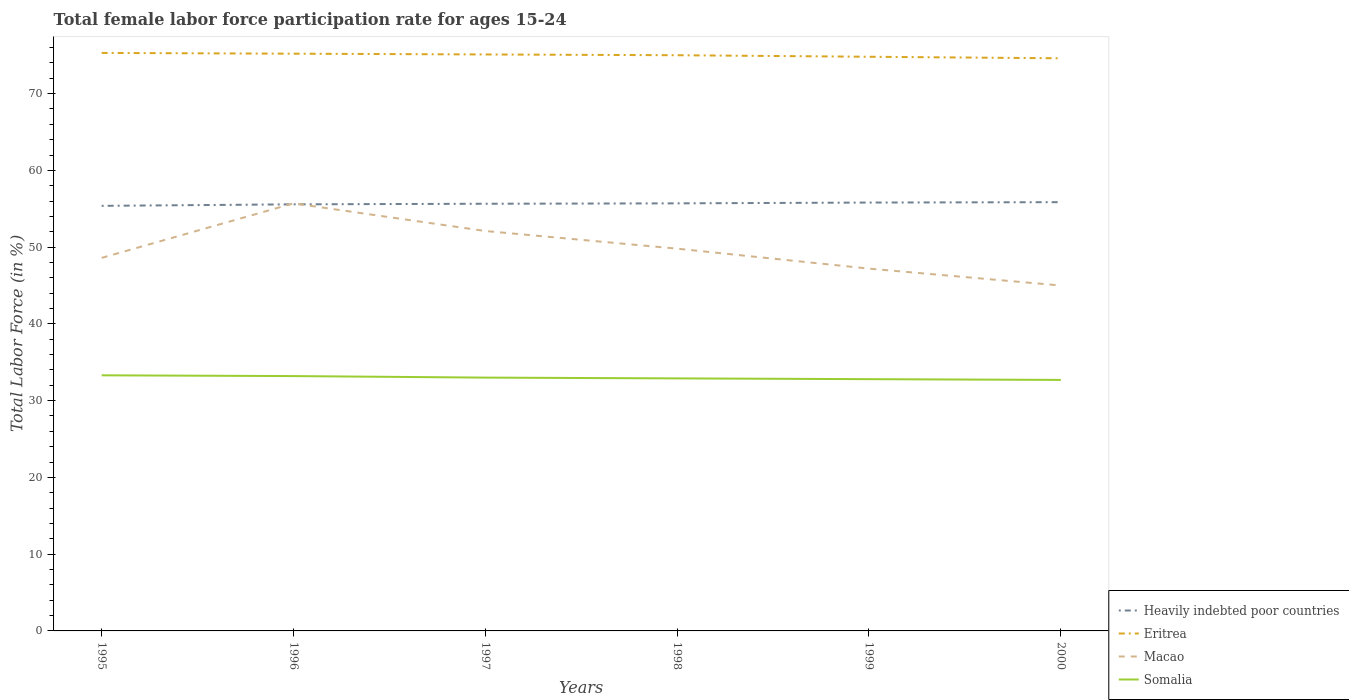Does the line corresponding to Somalia intersect with the line corresponding to Macao?
Offer a terse response. No. Across all years, what is the maximum female labor force participation rate in Heavily indebted poor countries?
Your answer should be compact. 55.38. In which year was the female labor force participation rate in Macao maximum?
Your answer should be very brief. 2000. What is the total female labor force participation rate in Eritrea in the graph?
Give a very brief answer. 0.1. What is the difference between the highest and the second highest female labor force participation rate in Somalia?
Keep it short and to the point. 0.6. What is the difference between the highest and the lowest female labor force participation rate in Heavily indebted poor countries?
Offer a terse response. 3. Is the female labor force participation rate in Heavily indebted poor countries strictly greater than the female labor force participation rate in Somalia over the years?
Offer a very short reply. No. Are the values on the major ticks of Y-axis written in scientific E-notation?
Keep it short and to the point. No. Does the graph contain grids?
Your answer should be very brief. No. Where does the legend appear in the graph?
Make the answer very short. Bottom right. What is the title of the graph?
Your answer should be very brief. Total female labor force participation rate for ages 15-24. What is the label or title of the X-axis?
Your response must be concise. Years. What is the Total Labor Force (in %) of Heavily indebted poor countries in 1995?
Provide a succinct answer. 55.38. What is the Total Labor Force (in %) of Eritrea in 1995?
Your answer should be compact. 75.3. What is the Total Labor Force (in %) in Macao in 1995?
Your response must be concise. 48.6. What is the Total Labor Force (in %) in Somalia in 1995?
Your response must be concise. 33.3. What is the Total Labor Force (in %) in Heavily indebted poor countries in 1996?
Keep it short and to the point. 55.57. What is the Total Labor Force (in %) in Eritrea in 1996?
Provide a succinct answer. 75.2. What is the Total Labor Force (in %) in Macao in 1996?
Keep it short and to the point. 55.7. What is the Total Labor Force (in %) of Somalia in 1996?
Offer a terse response. 33.2. What is the Total Labor Force (in %) in Heavily indebted poor countries in 1997?
Your response must be concise. 55.65. What is the Total Labor Force (in %) of Eritrea in 1997?
Give a very brief answer. 75.1. What is the Total Labor Force (in %) in Macao in 1997?
Make the answer very short. 52.1. What is the Total Labor Force (in %) in Heavily indebted poor countries in 1998?
Offer a very short reply. 55.7. What is the Total Labor Force (in %) of Eritrea in 1998?
Provide a short and direct response. 75. What is the Total Labor Force (in %) of Macao in 1998?
Offer a very short reply. 49.8. What is the Total Labor Force (in %) in Somalia in 1998?
Offer a very short reply. 32.9. What is the Total Labor Force (in %) of Heavily indebted poor countries in 1999?
Your answer should be compact. 55.81. What is the Total Labor Force (in %) in Eritrea in 1999?
Your answer should be compact. 74.8. What is the Total Labor Force (in %) in Macao in 1999?
Provide a succinct answer. 47.2. What is the Total Labor Force (in %) in Somalia in 1999?
Provide a short and direct response. 32.8. What is the Total Labor Force (in %) in Heavily indebted poor countries in 2000?
Your answer should be compact. 55.86. What is the Total Labor Force (in %) of Eritrea in 2000?
Your answer should be compact. 74.6. What is the Total Labor Force (in %) in Macao in 2000?
Provide a succinct answer. 45. What is the Total Labor Force (in %) in Somalia in 2000?
Provide a succinct answer. 32.7. Across all years, what is the maximum Total Labor Force (in %) in Heavily indebted poor countries?
Offer a terse response. 55.86. Across all years, what is the maximum Total Labor Force (in %) in Eritrea?
Your response must be concise. 75.3. Across all years, what is the maximum Total Labor Force (in %) of Macao?
Your response must be concise. 55.7. Across all years, what is the maximum Total Labor Force (in %) in Somalia?
Ensure brevity in your answer.  33.3. Across all years, what is the minimum Total Labor Force (in %) of Heavily indebted poor countries?
Make the answer very short. 55.38. Across all years, what is the minimum Total Labor Force (in %) in Eritrea?
Offer a terse response. 74.6. Across all years, what is the minimum Total Labor Force (in %) in Macao?
Give a very brief answer. 45. Across all years, what is the minimum Total Labor Force (in %) of Somalia?
Give a very brief answer. 32.7. What is the total Total Labor Force (in %) of Heavily indebted poor countries in the graph?
Your response must be concise. 333.97. What is the total Total Labor Force (in %) of Eritrea in the graph?
Offer a terse response. 450. What is the total Total Labor Force (in %) in Macao in the graph?
Keep it short and to the point. 298.4. What is the total Total Labor Force (in %) in Somalia in the graph?
Provide a succinct answer. 197.9. What is the difference between the Total Labor Force (in %) in Heavily indebted poor countries in 1995 and that in 1996?
Your response must be concise. -0.2. What is the difference between the Total Labor Force (in %) of Eritrea in 1995 and that in 1996?
Ensure brevity in your answer.  0.1. What is the difference between the Total Labor Force (in %) in Macao in 1995 and that in 1996?
Make the answer very short. -7.1. What is the difference between the Total Labor Force (in %) in Somalia in 1995 and that in 1996?
Your answer should be very brief. 0.1. What is the difference between the Total Labor Force (in %) of Heavily indebted poor countries in 1995 and that in 1997?
Keep it short and to the point. -0.27. What is the difference between the Total Labor Force (in %) of Eritrea in 1995 and that in 1997?
Give a very brief answer. 0.2. What is the difference between the Total Labor Force (in %) of Heavily indebted poor countries in 1995 and that in 1998?
Offer a terse response. -0.33. What is the difference between the Total Labor Force (in %) of Heavily indebted poor countries in 1995 and that in 1999?
Your response must be concise. -0.43. What is the difference between the Total Labor Force (in %) in Macao in 1995 and that in 1999?
Offer a very short reply. 1.4. What is the difference between the Total Labor Force (in %) of Somalia in 1995 and that in 1999?
Keep it short and to the point. 0.5. What is the difference between the Total Labor Force (in %) of Heavily indebted poor countries in 1995 and that in 2000?
Your answer should be compact. -0.48. What is the difference between the Total Labor Force (in %) of Eritrea in 1995 and that in 2000?
Your response must be concise. 0.7. What is the difference between the Total Labor Force (in %) of Heavily indebted poor countries in 1996 and that in 1997?
Ensure brevity in your answer.  -0.08. What is the difference between the Total Labor Force (in %) in Eritrea in 1996 and that in 1997?
Provide a short and direct response. 0.1. What is the difference between the Total Labor Force (in %) in Heavily indebted poor countries in 1996 and that in 1998?
Offer a very short reply. -0.13. What is the difference between the Total Labor Force (in %) in Macao in 1996 and that in 1998?
Make the answer very short. 5.9. What is the difference between the Total Labor Force (in %) in Somalia in 1996 and that in 1998?
Give a very brief answer. 0.3. What is the difference between the Total Labor Force (in %) in Heavily indebted poor countries in 1996 and that in 1999?
Your answer should be compact. -0.23. What is the difference between the Total Labor Force (in %) of Macao in 1996 and that in 1999?
Offer a very short reply. 8.5. What is the difference between the Total Labor Force (in %) in Somalia in 1996 and that in 1999?
Provide a short and direct response. 0.4. What is the difference between the Total Labor Force (in %) of Heavily indebted poor countries in 1996 and that in 2000?
Provide a short and direct response. -0.28. What is the difference between the Total Labor Force (in %) in Somalia in 1996 and that in 2000?
Offer a very short reply. 0.5. What is the difference between the Total Labor Force (in %) of Heavily indebted poor countries in 1997 and that in 1998?
Keep it short and to the point. -0.05. What is the difference between the Total Labor Force (in %) of Eritrea in 1997 and that in 1998?
Offer a very short reply. 0.1. What is the difference between the Total Labor Force (in %) in Somalia in 1997 and that in 1998?
Your answer should be very brief. 0.1. What is the difference between the Total Labor Force (in %) in Heavily indebted poor countries in 1997 and that in 1999?
Your response must be concise. -0.16. What is the difference between the Total Labor Force (in %) in Eritrea in 1997 and that in 1999?
Provide a succinct answer. 0.3. What is the difference between the Total Labor Force (in %) of Macao in 1997 and that in 1999?
Provide a short and direct response. 4.9. What is the difference between the Total Labor Force (in %) of Somalia in 1997 and that in 1999?
Offer a terse response. 0.2. What is the difference between the Total Labor Force (in %) in Heavily indebted poor countries in 1997 and that in 2000?
Make the answer very short. -0.21. What is the difference between the Total Labor Force (in %) in Eritrea in 1997 and that in 2000?
Make the answer very short. 0.5. What is the difference between the Total Labor Force (in %) of Macao in 1997 and that in 2000?
Keep it short and to the point. 7.1. What is the difference between the Total Labor Force (in %) of Heavily indebted poor countries in 1998 and that in 1999?
Your answer should be very brief. -0.1. What is the difference between the Total Labor Force (in %) of Eritrea in 1998 and that in 1999?
Make the answer very short. 0.2. What is the difference between the Total Labor Force (in %) of Macao in 1998 and that in 1999?
Offer a very short reply. 2.6. What is the difference between the Total Labor Force (in %) of Heavily indebted poor countries in 1998 and that in 2000?
Your answer should be very brief. -0.15. What is the difference between the Total Labor Force (in %) of Macao in 1998 and that in 2000?
Provide a short and direct response. 4.8. What is the difference between the Total Labor Force (in %) of Heavily indebted poor countries in 1999 and that in 2000?
Ensure brevity in your answer.  -0.05. What is the difference between the Total Labor Force (in %) in Heavily indebted poor countries in 1995 and the Total Labor Force (in %) in Eritrea in 1996?
Your answer should be compact. -19.82. What is the difference between the Total Labor Force (in %) in Heavily indebted poor countries in 1995 and the Total Labor Force (in %) in Macao in 1996?
Provide a succinct answer. -0.32. What is the difference between the Total Labor Force (in %) of Heavily indebted poor countries in 1995 and the Total Labor Force (in %) of Somalia in 1996?
Your response must be concise. 22.18. What is the difference between the Total Labor Force (in %) in Eritrea in 1995 and the Total Labor Force (in %) in Macao in 1996?
Provide a short and direct response. 19.6. What is the difference between the Total Labor Force (in %) in Eritrea in 1995 and the Total Labor Force (in %) in Somalia in 1996?
Your answer should be compact. 42.1. What is the difference between the Total Labor Force (in %) in Macao in 1995 and the Total Labor Force (in %) in Somalia in 1996?
Keep it short and to the point. 15.4. What is the difference between the Total Labor Force (in %) in Heavily indebted poor countries in 1995 and the Total Labor Force (in %) in Eritrea in 1997?
Your answer should be compact. -19.72. What is the difference between the Total Labor Force (in %) in Heavily indebted poor countries in 1995 and the Total Labor Force (in %) in Macao in 1997?
Offer a terse response. 3.28. What is the difference between the Total Labor Force (in %) of Heavily indebted poor countries in 1995 and the Total Labor Force (in %) of Somalia in 1997?
Your response must be concise. 22.38. What is the difference between the Total Labor Force (in %) of Eritrea in 1995 and the Total Labor Force (in %) of Macao in 1997?
Offer a very short reply. 23.2. What is the difference between the Total Labor Force (in %) in Eritrea in 1995 and the Total Labor Force (in %) in Somalia in 1997?
Make the answer very short. 42.3. What is the difference between the Total Labor Force (in %) in Heavily indebted poor countries in 1995 and the Total Labor Force (in %) in Eritrea in 1998?
Provide a short and direct response. -19.62. What is the difference between the Total Labor Force (in %) in Heavily indebted poor countries in 1995 and the Total Labor Force (in %) in Macao in 1998?
Offer a terse response. 5.58. What is the difference between the Total Labor Force (in %) of Heavily indebted poor countries in 1995 and the Total Labor Force (in %) of Somalia in 1998?
Your answer should be compact. 22.48. What is the difference between the Total Labor Force (in %) in Eritrea in 1995 and the Total Labor Force (in %) in Somalia in 1998?
Offer a terse response. 42.4. What is the difference between the Total Labor Force (in %) in Macao in 1995 and the Total Labor Force (in %) in Somalia in 1998?
Give a very brief answer. 15.7. What is the difference between the Total Labor Force (in %) in Heavily indebted poor countries in 1995 and the Total Labor Force (in %) in Eritrea in 1999?
Ensure brevity in your answer.  -19.42. What is the difference between the Total Labor Force (in %) of Heavily indebted poor countries in 1995 and the Total Labor Force (in %) of Macao in 1999?
Provide a succinct answer. 8.18. What is the difference between the Total Labor Force (in %) of Heavily indebted poor countries in 1995 and the Total Labor Force (in %) of Somalia in 1999?
Ensure brevity in your answer.  22.58. What is the difference between the Total Labor Force (in %) in Eritrea in 1995 and the Total Labor Force (in %) in Macao in 1999?
Ensure brevity in your answer.  28.1. What is the difference between the Total Labor Force (in %) of Eritrea in 1995 and the Total Labor Force (in %) of Somalia in 1999?
Provide a short and direct response. 42.5. What is the difference between the Total Labor Force (in %) of Heavily indebted poor countries in 1995 and the Total Labor Force (in %) of Eritrea in 2000?
Ensure brevity in your answer.  -19.22. What is the difference between the Total Labor Force (in %) in Heavily indebted poor countries in 1995 and the Total Labor Force (in %) in Macao in 2000?
Offer a terse response. 10.38. What is the difference between the Total Labor Force (in %) of Heavily indebted poor countries in 1995 and the Total Labor Force (in %) of Somalia in 2000?
Your response must be concise. 22.68. What is the difference between the Total Labor Force (in %) of Eritrea in 1995 and the Total Labor Force (in %) of Macao in 2000?
Your answer should be compact. 30.3. What is the difference between the Total Labor Force (in %) of Eritrea in 1995 and the Total Labor Force (in %) of Somalia in 2000?
Keep it short and to the point. 42.6. What is the difference between the Total Labor Force (in %) of Heavily indebted poor countries in 1996 and the Total Labor Force (in %) of Eritrea in 1997?
Ensure brevity in your answer.  -19.53. What is the difference between the Total Labor Force (in %) of Heavily indebted poor countries in 1996 and the Total Labor Force (in %) of Macao in 1997?
Ensure brevity in your answer.  3.47. What is the difference between the Total Labor Force (in %) of Heavily indebted poor countries in 1996 and the Total Labor Force (in %) of Somalia in 1997?
Your response must be concise. 22.57. What is the difference between the Total Labor Force (in %) in Eritrea in 1996 and the Total Labor Force (in %) in Macao in 1997?
Provide a succinct answer. 23.1. What is the difference between the Total Labor Force (in %) in Eritrea in 1996 and the Total Labor Force (in %) in Somalia in 1997?
Your answer should be compact. 42.2. What is the difference between the Total Labor Force (in %) in Macao in 1996 and the Total Labor Force (in %) in Somalia in 1997?
Your answer should be compact. 22.7. What is the difference between the Total Labor Force (in %) in Heavily indebted poor countries in 1996 and the Total Labor Force (in %) in Eritrea in 1998?
Your answer should be very brief. -19.43. What is the difference between the Total Labor Force (in %) in Heavily indebted poor countries in 1996 and the Total Labor Force (in %) in Macao in 1998?
Make the answer very short. 5.77. What is the difference between the Total Labor Force (in %) of Heavily indebted poor countries in 1996 and the Total Labor Force (in %) of Somalia in 1998?
Offer a terse response. 22.67. What is the difference between the Total Labor Force (in %) in Eritrea in 1996 and the Total Labor Force (in %) in Macao in 1998?
Offer a terse response. 25.4. What is the difference between the Total Labor Force (in %) of Eritrea in 1996 and the Total Labor Force (in %) of Somalia in 1998?
Offer a terse response. 42.3. What is the difference between the Total Labor Force (in %) of Macao in 1996 and the Total Labor Force (in %) of Somalia in 1998?
Keep it short and to the point. 22.8. What is the difference between the Total Labor Force (in %) in Heavily indebted poor countries in 1996 and the Total Labor Force (in %) in Eritrea in 1999?
Your answer should be compact. -19.23. What is the difference between the Total Labor Force (in %) in Heavily indebted poor countries in 1996 and the Total Labor Force (in %) in Macao in 1999?
Offer a very short reply. 8.37. What is the difference between the Total Labor Force (in %) of Heavily indebted poor countries in 1996 and the Total Labor Force (in %) of Somalia in 1999?
Offer a terse response. 22.77. What is the difference between the Total Labor Force (in %) in Eritrea in 1996 and the Total Labor Force (in %) in Somalia in 1999?
Provide a short and direct response. 42.4. What is the difference between the Total Labor Force (in %) of Macao in 1996 and the Total Labor Force (in %) of Somalia in 1999?
Keep it short and to the point. 22.9. What is the difference between the Total Labor Force (in %) of Heavily indebted poor countries in 1996 and the Total Labor Force (in %) of Eritrea in 2000?
Make the answer very short. -19.03. What is the difference between the Total Labor Force (in %) in Heavily indebted poor countries in 1996 and the Total Labor Force (in %) in Macao in 2000?
Make the answer very short. 10.57. What is the difference between the Total Labor Force (in %) in Heavily indebted poor countries in 1996 and the Total Labor Force (in %) in Somalia in 2000?
Offer a terse response. 22.87. What is the difference between the Total Labor Force (in %) in Eritrea in 1996 and the Total Labor Force (in %) in Macao in 2000?
Keep it short and to the point. 30.2. What is the difference between the Total Labor Force (in %) in Eritrea in 1996 and the Total Labor Force (in %) in Somalia in 2000?
Your response must be concise. 42.5. What is the difference between the Total Labor Force (in %) in Heavily indebted poor countries in 1997 and the Total Labor Force (in %) in Eritrea in 1998?
Offer a very short reply. -19.35. What is the difference between the Total Labor Force (in %) of Heavily indebted poor countries in 1997 and the Total Labor Force (in %) of Macao in 1998?
Make the answer very short. 5.85. What is the difference between the Total Labor Force (in %) in Heavily indebted poor countries in 1997 and the Total Labor Force (in %) in Somalia in 1998?
Your answer should be very brief. 22.75. What is the difference between the Total Labor Force (in %) in Eritrea in 1997 and the Total Labor Force (in %) in Macao in 1998?
Make the answer very short. 25.3. What is the difference between the Total Labor Force (in %) of Eritrea in 1997 and the Total Labor Force (in %) of Somalia in 1998?
Provide a short and direct response. 42.2. What is the difference between the Total Labor Force (in %) of Heavily indebted poor countries in 1997 and the Total Labor Force (in %) of Eritrea in 1999?
Offer a terse response. -19.15. What is the difference between the Total Labor Force (in %) in Heavily indebted poor countries in 1997 and the Total Labor Force (in %) in Macao in 1999?
Give a very brief answer. 8.45. What is the difference between the Total Labor Force (in %) of Heavily indebted poor countries in 1997 and the Total Labor Force (in %) of Somalia in 1999?
Give a very brief answer. 22.85. What is the difference between the Total Labor Force (in %) in Eritrea in 1997 and the Total Labor Force (in %) in Macao in 1999?
Ensure brevity in your answer.  27.9. What is the difference between the Total Labor Force (in %) in Eritrea in 1997 and the Total Labor Force (in %) in Somalia in 1999?
Your answer should be compact. 42.3. What is the difference between the Total Labor Force (in %) of Macao in 1997 and the Total Labor Force (in %) of Somalia in 1999?
Ensure brevity in your answer.  19.3. What is the difference between the Total Labor Force (in %) of Heavily indebted poor countries in 1997 and the Total Labor Force (in %) of Eritrea in 2000?
Provide a succinct answer. -18.95. What is the difference between the Total Labor Force (in %) in Heavily indebted poor countries in 1997 and the Total Labor Force (in %) in Macao in 2000?
Your response must be concise. 10.65. What is the difference between the Total Labor Force (in %) of Heavily indebted poor countries in 1997 and the Total Labor Force (in %) of Somalia in 2000?
Make the answer very short. 22.95. What is the difference between the Total Labor Force (in %) of Eritrea in 1997 and the Total Labor Force (in %) of Macao in 2000?
Provide a short and direct response. 30.1. What is the difference between the Total Labor Force (in %) in Eritrea in 1997 and the Total Labor Force (in %) in Somalia in 2000?
Your answer should be very brief. 42.4. What is the difference between the Total Labor Force (in %) in Macao in 1997 and the Total Labor Force (in %) in Somalia in 2000?
Your answer should be compact. 19.4. What is the difference between the Total Labor Force (in %) in Heavily indebted poor countries in 1998 and the Total Labor Force (in %) in Eritrea in 1999?
Make the answer very short. -19.1. What is the difference between the Total Labor Force (in %) in Heavily indebted poor countries in 1998 and the Total Labor Force (in %) in Macao in 1999?
Provide a succinct answer. 8.5. What is the difference between the Total Labor Force (in %) in Heavily indebted poor countries in 1998 and the Total Labor Force (in %) in Somalia in 1999?
Give a very brief answer. 22.9. What is the difference between the Total Labor Force (in %) in Eritrea in 1998 and the Total Labor Force (in %) in Macao in 1999?
Give a very brief answer. 27.8. What is the difference between the Total Labor Force (in %) of Eritrea in 1998 and the Total Labor Force (in %) of Somalia in 1999?
Keep it short and to the point. 42.2. What is the difference between the Total Labor Force (in %) of Heavily indebted poor countries in 1998 and the Total Labor Force (in %) of Eritrea in 2000?
Your answer should be compact. -18.9. What is the difference between the Total Labor Force (in %) in Heavily indebted poor countries in 1998 and the Total Labor Force (in %) in Macao in 2000?
Ensure brevity in your answer.  10.7. What is the difference between the Total Labor Force (in %) in Heavily indebted poor countries in 1998 and the Total Labor Force (in %) in Somalia in 2000?
Provide a short and direct response. 23. What is the difference between the Total Labor Force (in %) in Eritrea in 1998 and the Total Labor Force (in %) in Somalia in 2000?
Your answer should be very brief. 42.3. What is the difference between the Total Labor Force (in %) in Heavily indebted poor countries in 1999 and the Total Labor Force (in %) in Eritrea in 2000?
Offer a very short reply. -18.79. What is the difference between the Total Labor Force (in %) of Heavily indebted poor countries in 1999 and the Total Labor Force (in %) of Macao in 2000?
Keep it short and to the point. 10.81. What is the difference between the Total Labor Force (in %) of Heavily indebted poor countries in 1999 and the Total Labor Force (in %) of Somalia in 2000?
Your answer should be compact. 23.11. What is the difference between the Total Labor Force (in %) in Eritrea in 1999 and the Total Labor Force (in %) in Macao in 2000?
Give a very brief answer. 29.8. What is the difference between the Total Labor Force (in %) in Eritrea in 1999 and the Total Labor Force (in %) in Somalia in 2000?
Keep it short and to the point. 42.1. What is the average Total Labor Force (in %) in Heavily indebted poor countries per year?
Your answer should be compact. 55.66. What is the average Total Labor Force (in %) in Macao per year?
Your answer should be compact. 49.73. What is the average Total Labor Force (in %) in Somalia per year?
Offer a terse response. 32.98. In the year 1995, what is the difference between the Total Labor Force (in %) of Heavily indebted poor countries and Total Labor Force (in %) of Eritrea?
Your answer should be very brief. -19.92. In the year 1995, what is the difference between the Total Labor Force (in %) in Heavily indebted poor countries and Total Labor Force (in %) in Macao?
Your answer should be compact. 6.78. In the year 1995, what is the difference between the Total Labor Force (in %) of Heavily indebted poor countries and Total Labor Force (in %) of Somalia?
Provide a short and direct response. 22.08. In the year 1995, what is the difference between the Total Labor Force (in %) of Eritrea and Total Labor Force (in %) of Macao?
Give a very brief answer. 26.7. In the year 1996, what is the difference between the Total Labor Force (in %) of Heavily indebted poor countries and Total Labor Force (in %) of Eritrea?
Give a very brief answer. -19.63. In the year 1996, what is the difference between the Total Labor Force (in %) of Heavily indebted poor countries and Total Labor Force (in %) of Macao?
Ensure brevity in your answer.  -0.13. In the year 1996, what is the difference between the Total Labor Force (in %) in Heavily indebted poor countries and Total Labor Force (in %) in Somalia?
Offer a terse response. 22.37. In the year 1996, what is the difference between the Total Labor Force (in %) in Eritrea and Total Labor Force (in %) in Macao?
Offer a terse response. 19.5. In the year 1996, what is the difference between the Total Labor Force (in %) in Eritrea and Total Labor Force (in %) in Somalia?
Provide a short and direct response. 42. In the year 1997, what is the difference between the Total Labor Force (in %) of Heavily indebted poor countries and Total Labor Force (in %) of Eritrea?
Provide a succinct answer. -19.45. In the year 1997, what is the difference between the Total Labor Force (in %) of Heavily indebted poor countries and Total Labor Force (in %) of Macao?
Give a very brief answer. 3.55. In the year 1997, what is the difference between the Total Labor Force (in %) in Heavily indebted poor countries and Total Labor Force (in %) in Somalia?
Provide a short and direct response. 22.65. In the year 1997, what is the difference between the Total Labor Force (in %) in Eritrea and Total Labor Force (in %) in Macao?
Your answer should be compact. 23. In the year 1997, what is the difference between the Total Labor Force (in %) in Eritrea and Total Labor Force (in %) in Somalia?
Keep it short and to the point. 42.1. In the year 1998, what is the difference between the Total Labor Force (in %) in Heavily indebted poor countries and Total Labor Force (in %) in Eritrea?
Your response must be concise. -19.3. In the year 1998, what is the difference between the Total Labor Force (in %) of Heavily indebted poor countries and Total Labor Force (in %) of Macao?
Offer a very short reply. 5.9. In the year 1998, what is the difference between the Total Labor Force (in %) of Heavily indebted poor countries and Total Labor Force (in %) of Somalia?
Your answer should be compact. 22.8. In the year 1998, what is the difference between the Total Labor Force (in %) of Eritrea and Total Labor Force (in %) of Macao?
Give a very brief answer. 25.2. In the year 1998, what is the difference between the Total Labor Force (in %) in Eritrea and Total Labor Force (in %) in Somalia?
Your response must be concise. 42.1. In the year 1999, what is the difference between the Total Labor Force (in %) of Heavily indebted poor countries and Total Labor Force (in %) of Eritrea?
Provide a short and direct response. -18.99. In the year 1999, what is the difference between the Total Labor Force (in %) of Heavily indebted poor countries and Total Labor Force (in %) of Macao?
Your answer should be very brief. 8.61. In the year 1999, what is the difference between the Total Labor Force (in %) of Heavily indebted poor countries and Total Labor Force (in %) of Somalia?
Provide a succinct answer. 23.01. In the year 1999, what is the difference between the Total Labor Force (in %) in Eritrea and Total Labor Force (in %) in Macao?
Your answer should be very brief. 27.6. In the year 1999, what is the difference between the Total Labor Force (in %) of Eritrea and Total Labor Force (in %) of Somalia?
Provide a succinct answer. 42. In the year 2000, what is the difference between the Total Labor Force (in %) in Heavily indebted poor countries and Total Labor Force (in %) in Eritrea?
Offer a terse response. -18.74. In the year 2000, what is the difference between the Total Labor Force (in %) in Heavily indebted poor countries and Total Labor Force (in %) in Macao?
Give a very brief answer. 10.86. In the year 2000, what is the difference between the Total Labor Force (in %) in Heavily indebted poor countries and Total Labor Force (in %) in Somalia?
Offer a very short reply. 23.16. In the year 2000, what is the difference between the Total Labor Force (in %) in Eritrea and Total Labor Force (in %) in Macao?
Keep it short and to the point. 29.6. In the year 2000, what is the difference between the Total Labor Force (in %) of Eritrea and Total Labor Force (in %) of Somalia?
Offer a very short reply. 41.9. What is the ratio of the Total Labor Force (in %) in Eritrea in 1995 to that in 1996?
Ensure brevity in your answer.  1. What is the ratio of the Total Labor Force (in %) in Macao in 1995 to that in 1996?
Your response must be concise. 0.87. What is the ratio of the Total Labor Force (in %) in Eritrea in 1995 to that in 1997?
Your answer should be compact. 1. What is the ratio of the Total Labor Force (in %) of Macao in 1995 to that in 1997?
Your answer should be compact. 0.93. What is the ratio of the Total Labor Force (in %) of Somalia in 1995 to that in 1997?
Your answer should be very brief. 1.01. What is the ratio of the Total Labor Force (in %) of Macao in 1995 to that in 1998?
Your answer should be compact. 0.98. What is the ratio of the Total Labor Force (in %) in Somalia in 1995 to that in 1998?
Your response must be concise. 1.01. What is the ratio of the Total Labor Force (in %) in Heavily indebted poor countries in 1995 to that in 1999?
Offer a terse response. 0.99. What is the ratio of the Total Labor Force (in %) in Eritrea in 1995 to that in 1999?
Offer a very short reply. 1.01. What is the ratio of the Total Labor Force (in %) of Macao in 1995 to that in 1999?
Your answer should be compact. 1.03. What is the ratio of the Total Labor Force (in %) of Somalia in 1995 to that in 1999?
Offer a very short reply. 1.02. What is the ratio of the Total Labor Force (in %) in Eritrea in 1995 to that in 2000?
Your answer should be very brief. 1.01. What is the ratio of the Total Labor Force (in %) of Macao in 1995 to that in 2000?
Your answer should be very brief. 1.08. What is the ratio of the Total Labor Force (in %) in Somalia in 1995 to that in 2000?
Give a very brief answer. 1.02. What is the ratio of the Total Labor Force (in %) in Eritrea in 1996 to that in 1997?
Give a very brief answer. 1. What is the ratio of the Total Labor Force (in %) in Macao in 1996 to that in 1997?
Offer a very short reply. 1.07. What is the ratio of the Total Labor Force (in %) of Somalia in 1996 to that in 1997?
Provide a short and direct response. 1.01. What is the ratio of the Total Labor Force (in %) of Eritrea in 1996 to that in 1998?
Your answer should be compact. 1. What is the ratio of the Total Labor Force (in %) of Macao in 1996 to that in 1998?
Ensure brevity in your answer.  1.12. What is the ratio of the Total Labor Force (in %) of Somalia in 1996 to that in 1998?
Give a very brief answer. 1.01. What is the ratio of the Total Labor Force (in %) of Eritrea in 1996 to that in 1999?
Give a very brief answer. 1.01. What is the ratio of the Total Labor Force (in %) of Macao in 1996 to that in 1999?
Make the answer very short. 1.18. What is the ratio of the Total Labor Force (in %) in Somalia in 1996 to that in 1999?
Your response must be concise. 1.01. What is the ratio of the Total Labor Force (in %) in Heavily indebted poor countries in 1996 to that in 2000?
Your answer should be compact. 0.99. What is the ratio of the Total Labor Force (in %) in Eritrea in 1996 to that in 2000?
Offer a very short reply. 1.01. What is the ratio of the Total Labor Force (in %) in Macao in 1996 to that in 2000?
Your response must be concise. 1.24. What is the ratio of the Total Labor Force (in %) of Somalia in 1996 to that in 2000?
Your response must be concise. 1.02. What is the ratio of the Total Labor Force (in %) in Macao in 1997 to that in 1998?
Ensure brevity in your answer.  1.05. What is the ratio of the Total Labor Force (in %) in Macao in 1997 to that in 1999?
Offer a very short reply. 1.1. What is the ratio of the Total Labor Force (in %) in Macao in 1997 to that in 2000?
Keep it short and to the point. 1.16. What is the ratio of the Total Labor Force (in %) of Somalia in 1997 to that in 2000?
Keep it short and to the point. 1.01. What is the ratio of the Total Labor Force (in %) in Heavily indebted poor countries in 1998 to that in 1999?
Provide a succinct answer. 1. What is the ratio of the Total Labor Force (in %) in Macao in 1998 to that in 1999?
Provide a short and direct response. 1.06. What is the ratio of the Total Labor Force (in %) in Heavily indebted poor countries in 1998 to that in 2000?
Your response must be concise. 1. What is the ratio of the Total Labor Force (in %) of Eritrea in 1998 to that in 2000?
Offer a terse response. 1.01. What is the ratio of the Total Labor Force (in %) of Macao in 1998 to that in 2000?
Offer a terse response. 1.11. What is the ratio of the Total Labor Force (in %) in Heavily indebted poor countries in 1999 to that in 2000?
Ensure brevity in your answer.  1. What is the ratio of the Total Labor Force (in %) of Macao in 1999 to that in 2000?
Your answer should be compact. 1.05. What is the ratio of the Total Labor Force (in %) in Somalia in 1999 to that in 2000?
Your answer should be compact. 1. What is the difference between the highest and the second highest Total Labor Force (in %) in Heavily indebted poor countries?
Your response must be concise. 0.05. What is the difference between the highest and the second highest Total Labor Force (in %) in Eritrea?
Offer a very short reply. 0.1. What is the difference between the highest and the second highest Total Labor Force (in %) of Macao?
Make the answer very short. 3.6. What is the difference between the highest and the second highest Total Labor Force (in %) in Somalia?
Offer a very short reply. 0.1. What is the difference between the highest and the lowest Total Labor Force (in %) in Heavily indebted poor countries?
Provide a short and direct response. 0.48. What is the difference between the highest and the lowest Total Labor Force (in %) in Eritrea?
Provide a succinct answer. 0.7. What is the difference between the highest and the lowest Total Labor Force (in %) of Macao?
Ensure brevity in your answer.  10.7. What is the difference between the highest and the lowest Total Labor Force (in %) in Somalia?
Your answer should be very brief. 0.6. 